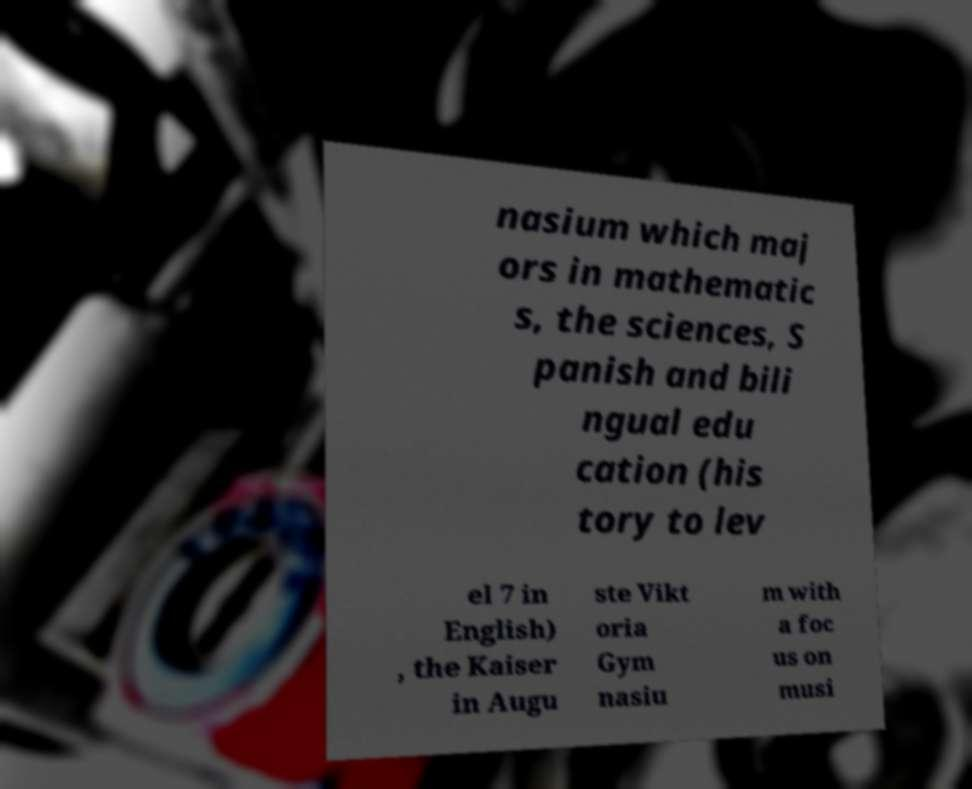There's text embedded in this image that I need extracted. Can you transcribe it verbatim? nasium which maj ors in mathematic s, the sciences, S panish and bili ngual edu cation (his tory to lev el 7 in English) , the Kaiser in Augu ste Vikt oria Gym nasiu m with a foc us on musi 